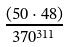<formula> <loc_0><loc_0><loc_500><loc_500>\frac { ( 5 0 \cdot 4 8 ) } { 3 7 0 ^ { 3 1 1 } }</formula> 